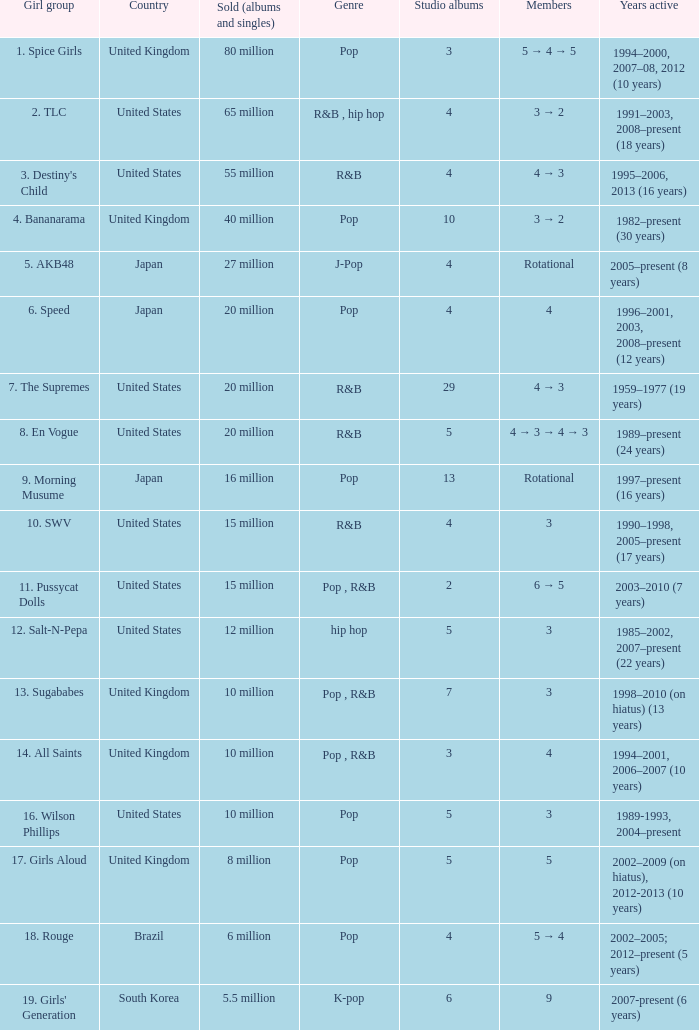How many members were in the group that sold 65 million albums and singles? 3 → 2. 